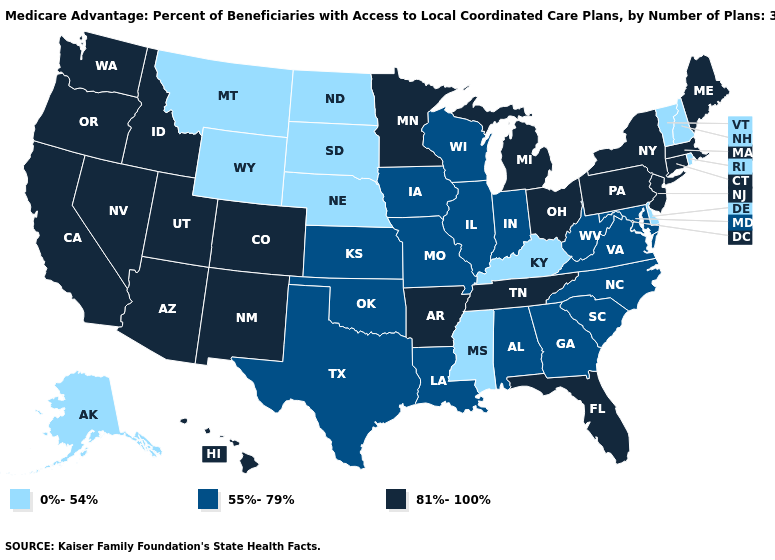What is the lowest value in states that border Utah?
Quick response, please. 0%-54%. Which states have the lowest value in the USA?
Write a very short answer. Alaska, Delaware, Kentucky, Mississippi, Montana, North Dakota, Nebraska, New Hampshire, Rhode Island, South Dakota, Vermont, Wyoming. Among the states that border Minnesota , which have the lowest value?
Short answer required. North Dakota, South Dakota. Which states have the lowest value in the Northeast?
Be succinct. New Hampshire, Rhode Island, Vermont. What is the value of Ohio?
Write a very short answer. 81%-100%. Does the first symbol in the legend represent the smallest category?
Concise answer only. Yes. What is the highest value in states that border Indiana?
Concise answer only. 81%-100%. Does Wyoming have the highest value in the West?
Quick response, please. No. Does Connecticut have a higher value than South Dakota?
Write a very short answer. Yes. Does Arizona have a lower value than Connecticut?
Short answer required. No. Does Wyoming have the highest value in the West?
Concise answer only. No. Is the legend a continuous bar?
Be succinct. No. Name the states that have a value in the range 55%-79%?
Keep it brief. Alabama, Georgia, Iowa, Illinois, Indiana, Kansas, Louisiana, Maryland, Missouri, North Carolina, Oklahoma, South Carolina, Texas, Virginia, Wisconsin, West Virginia. What is the highest value in the USA?
Keep it brief. 81%-100%. 